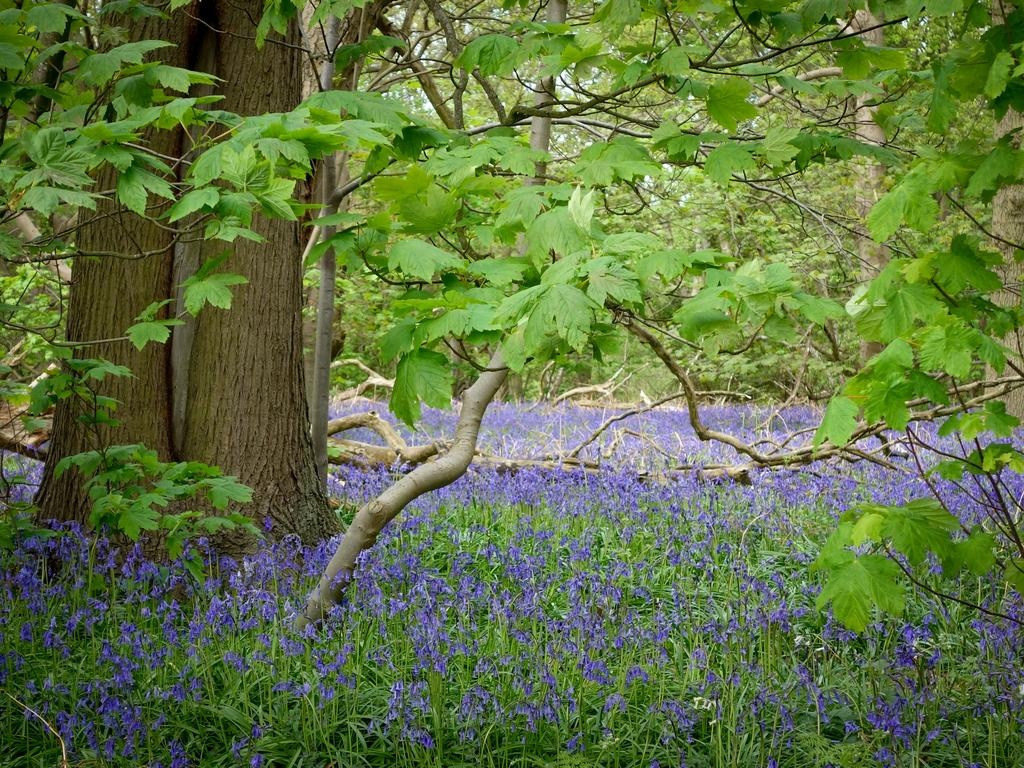What type of vegetation can be seen in the image? There are plants, flowers, and trees in the image. Can you describe the specific types of plants in the image? The image contains flowers and trees, but the specific types of plants cannot be determined from the image alone. What is the primary color of the flowers in the image? The primary color of the flowers in the image cannot be determined from the image alone. What type of coast can be seen in the image? There is no coast present in the image; it features plants, flowers, and trees. Can you hear the thunder in the image? There is no sound present in the image, so it is not possible to hear thunder. 